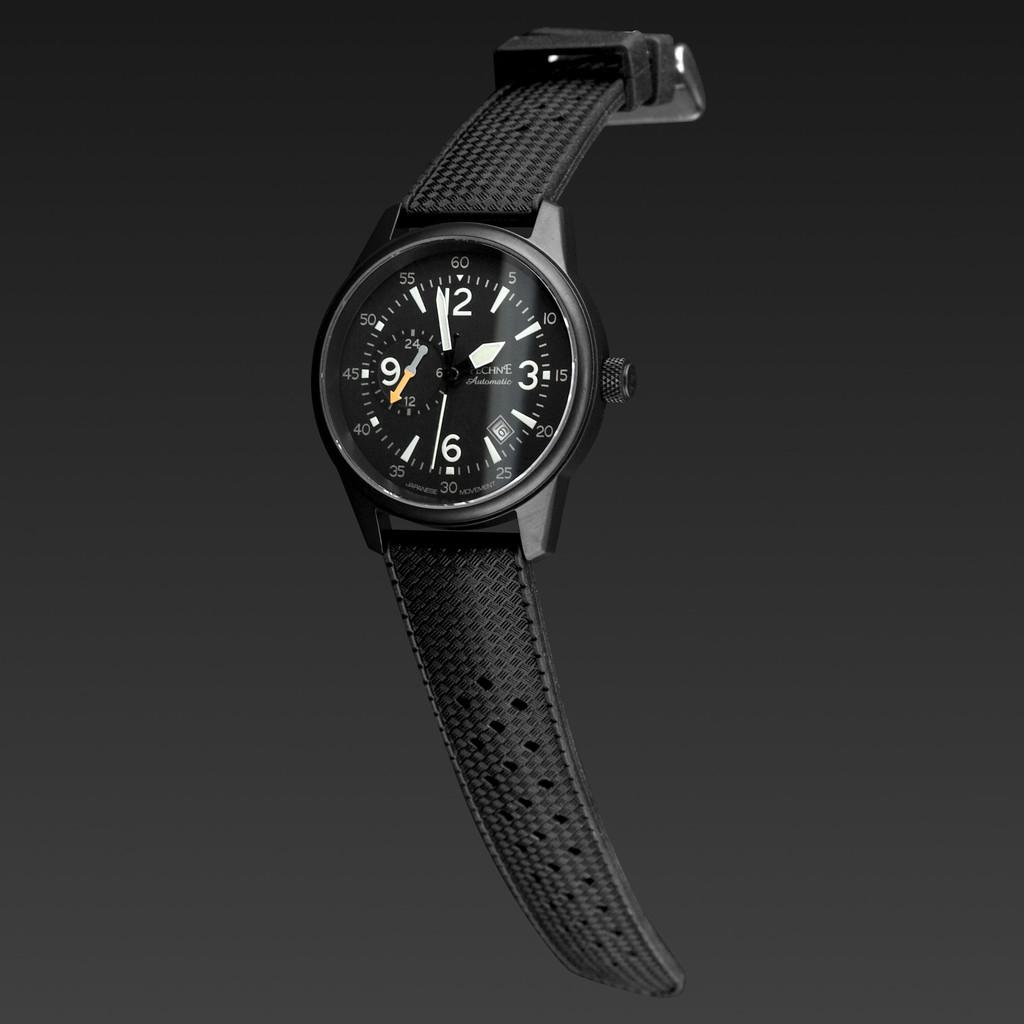<image>
Describe the image concisely. Black watch which has the yellow hand on the number 40. 